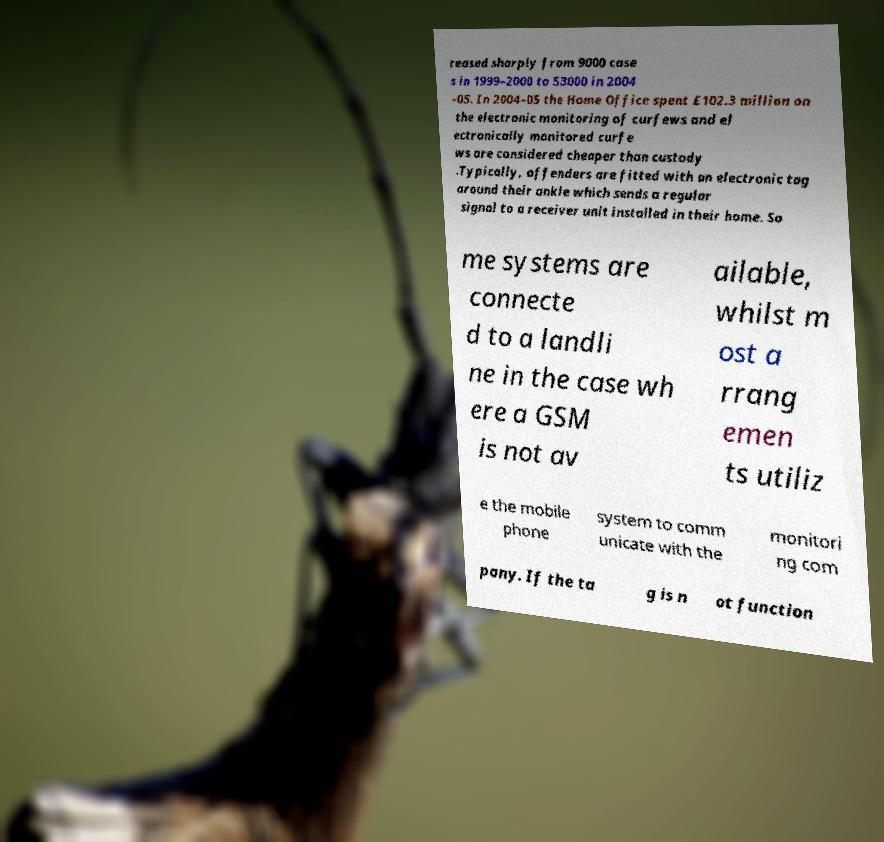Can you accurately transcribe the text from the provided image for me? reased sharply from 9000 case s in 1999–2000 to 53000 in 2004 –05. In 2004–05 the Home Office spent £102.3 million on the electronic monitoring of curfews and el ectronically monitored curfe ws are considered cheaper than custody .Typically, offenders are fitted with an electronic tag around their ankle which sends a regular signal to a receiver unit installed in their home. So me systems are connecte d to a landli ne in the case wh ere a GSM is not av ailable, whilst m ost a rrang emen ts utiliz e the mobile phone system to comm unicate with the monitori ng com pany. If the ta g is n ot function 